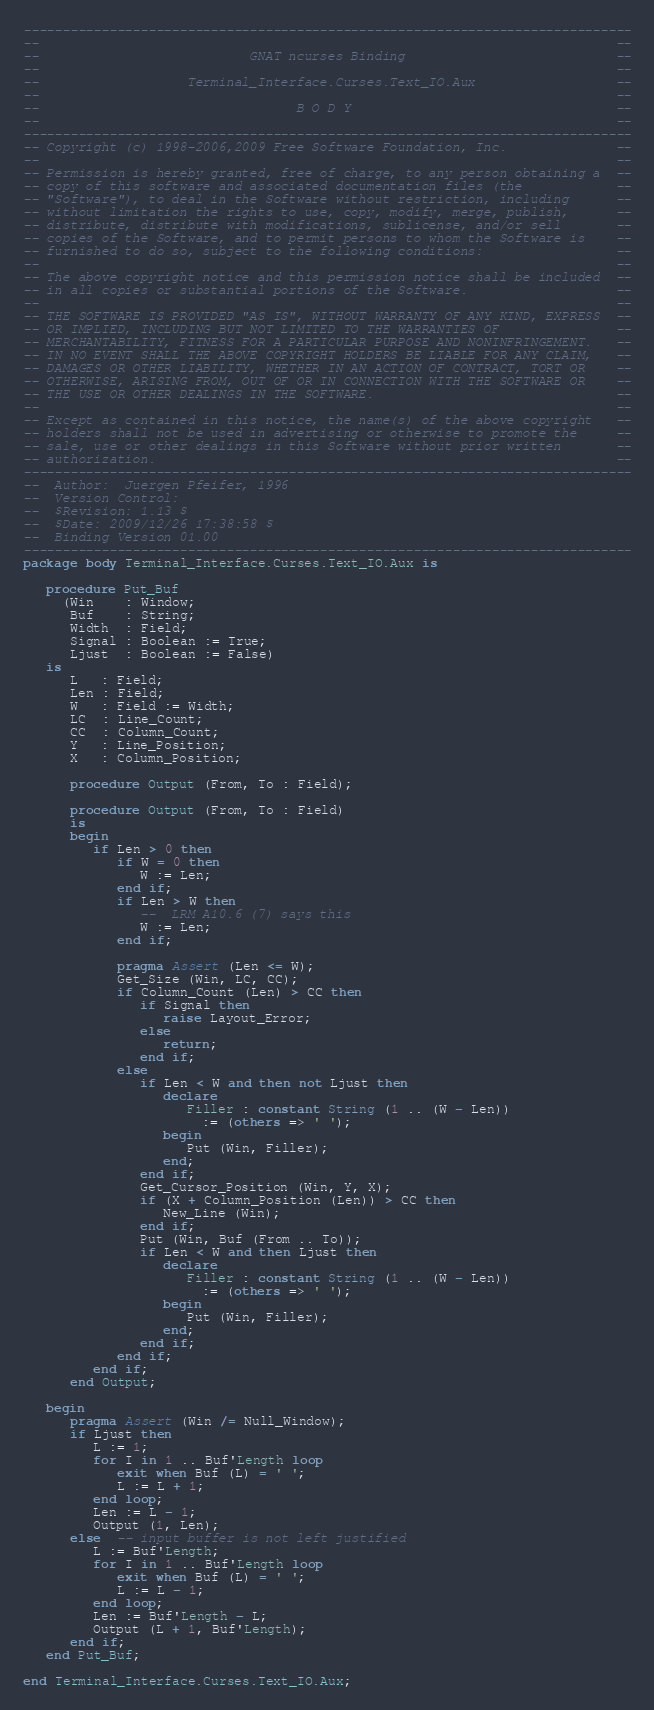Convert code to text. <code><loc_0><loc_0><loc_500><loc_500><_Ada_>------------------------------------------------------------------------------
--                                                                          --
--                           GNAT ncurses Binding                           --
--                                                                          --
--                   Terminal_Interface.Curses.Text_IO.Aux                  --
--                                                                          --
--                                 B O D Y                                  --
--                                                                          --
------------------------------------------------------------------------------
-- Copyright (c) 1998-2006,2009 Free Software Foundation, Inc.              --
--                                                                          --
-- Permission is hereby granted, free of charge, to any person obtaining a  --
-- copy of this software and associated documentation files (the            --
-- "Software"), to deal in the Software without restriction, including      --
-- without limitation the rights to use, copy, modify, merge, publish,      --
-- distribute, distribute with modifications, sublicense, and/or sell       --
-- copies of the Software, and to permit persons to whom the Software is    --
-- furnished to do so, subject to the following conditions:                 --
--                                                                          --
-- The above copyright notice and this permission notice shall be included  --
-- in all copies or substantial portions of the Software.                   --
--                                                                          --
-- THE SOFTWARE IS PROVIDED "AS IS", WITHOUT WARRANTY OF ANY KIND, EXPRESS  --
-- OR IMPLIED, INCLUDING BUT NOT LIMITED TO THE WARRANTIES OF               --
-- MERCHANTABILITY, FITNESS FOR A PARTICULAR PURPOSE AND NONINFRINGEMENT.   --
-- IN NO EVENT SHALL THE ABOVE COPYRIGHT HOLDERS BE LIABLE FOR ANY CLAIM,   --
-- DAMAGES OR OTHER LIABILITY, WHETHER IN AN ACTION OF CONTRACT, TORT OR    --
-- OTHERWISE, ARISING FROM, OUT OF OR IN CONNECTION WITH THE SOFTWARE OR    --
-- THE USE OR OTHER DEALINGS IN THE SOFTWARE.                               --
--                                                                          --
-- Except as contained in this notice, the name(s) of the above copyright   --
-- holders shall not be used in advertising or otherwise to promote the     --
-- sale, use or other dealings in this Software without prior written       --
-- authorization.                                                           --
------------------------------------------------------------------------------
--  Author:  Juergen Pfeifer, 1996
--  Version Control:
--  $Revision: 1.13 $
--  $Date: 2009/12/26 17:38:58 $
--  Binding Version 01.00
------------------------------------------------------------------------------
package body Terminal_Interface.Curses.Text_IO.Aux is

   procedure Put_Buf
     (Win    : Window;
      Buf    : String;
      Width  : Field;
      Signal : Boolean := True;
      Ljust  : Boolean := False)
   is
      L   : Field;
      Len : Field;
      W   : Field := Width;
      LC  : Line_Count;
      CC  : Column_Count;
      Y   : Line_Position;
      X   : Column_Position;

      procedure Output (From, To : Field);

      procedure Output (From, To : Field)
      is
      begin
         if Len > 0 then
            if W = 0 then
               W := Len;
            end if;
            if Len > W then
               --  LRM A10.6 (7) says this
               W := Len;
            end if;

            pragma Assert (Len <= W);
            Get_Size (Win, LC, CC);
            if Column_Count (Len) > CC then
               if Signal then
                  raise Layout_Error;
               else
                  return;
               end if;
            else
               if Len < W and then not Ljust then
                  declare
                     Filler : constant String (1 .. (W - Len))
                       := (others => ' ');
                  begin
                     Put (Win, Filler);
                  end;
               end if;
               Get_Cursor_Position (Win, Y, X);
               if (X + Column_Position (Len)) > CC then
                  New_Line (Win);
               end if;
               Put (Win, Buf (From .. To));
               if Len < W and then Ljust then
                  declare
                     Filler : constant String (1 .. (W - Len))
                       := (others => ' ');
                  begin
                     Put (Win, Filler);
                  end;
               end if;
            end if;
         end if;
      end Output;

   begin
      pragma Assert (Win /= Null_Window);
      if Ljust then
         L := 1;
         for I in 1 .. Buf'Length loop
            exit when Buf (L) = ' ';
            L := L + 1;
         end loop;
         Len := L - 1;
         Output (1, Len);
      else  -- input buffer is not left justified
         L := Buf'Length;
         for I in 1 .. Buf'Length loop
            exit when Buf (L) = ' ';
            L := L - 1;
         end loop;
         Len := Buf'Length - L;
         Output (L + 1, Buf'Length);
      end if;
   end Put_Buf;

end Terminal_Interface.Curses.Text_IO.Aux;
</code> 